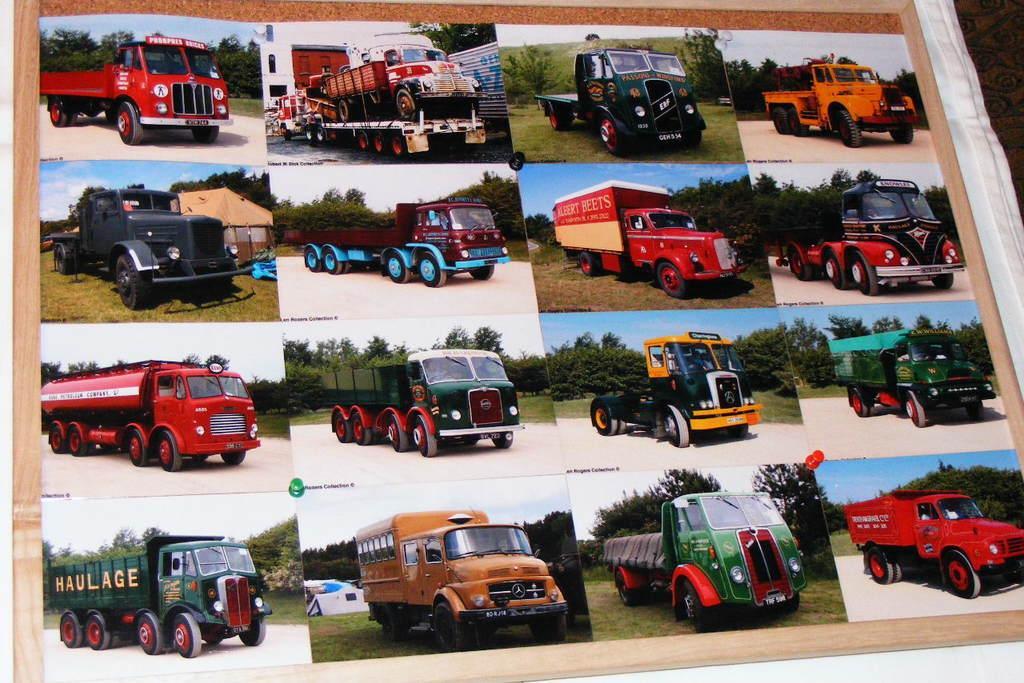In one or two sentences, can you explain what this image depicts? In this image we can see some photos of the vehicles pinned on a board which is placed on a cloth. 